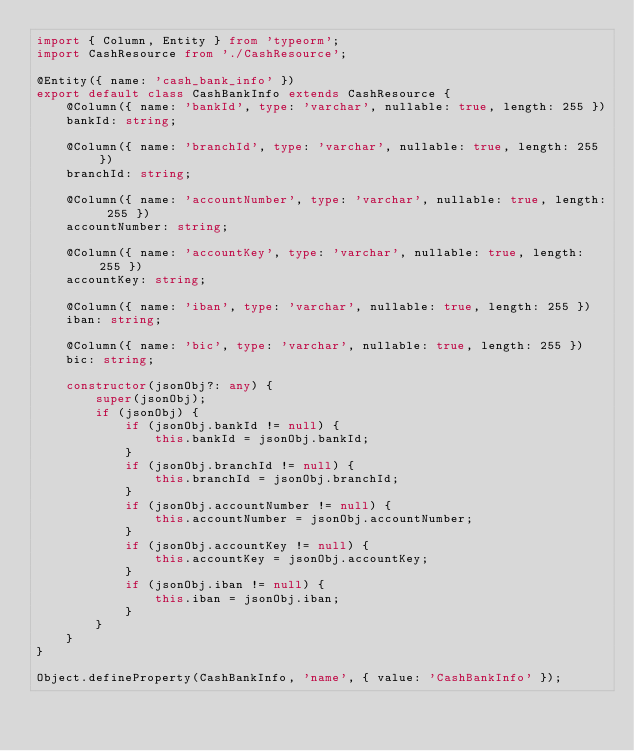Convert code to text. <code><loc_0><loc_0><loc_500><loc_500><_TypeScript_>import { Column, Entity } from 'typeorm';
import CashResource from './CashResource';

@Entity({ name: 'cash_bank_info' })
export default class CashBankInfo extends CashResource {
    @Column({ name: 'bankId', type: 'varchar', nullable: true, length: 255 })
    bankId: string;

    @Column({ name: 'branchId', type: 'varchar', nullable: true, length: 255 })
    branchId: string;

    @Column({ name: 'accountNumber', type: 'varchar', nullable: true, length: 255 })
    accountNumber: string;

    @Column({ name: 'accountKey', type: 'varchar', nullable: true, length: 255 })
    accountKey: string;

    @Column({ name: 'iban', type: 'varchar', nullable: true, length: 255 })
    iban: string;

    @Column({ name: 'bic', type: 'varchar', nullable: true, length: 255 })
    bic: string;

    constructor(jsonObj?: any) {
        super(jsonObj);
        if (jsonObj) {
            if (jsonObj.bankId != null) {
                this.bankId = jsonObj.bankId;
            }
            if (jsonObj.branchId != null) {
                this.branchId = jsonObj.branchId;
            }
            if (jsonObj.accountNumber != null) {
                this.accountNumber = jsonObj.accountNumber;
            }
            if (jsonObj.accountKey != null) {
                this.accountKey = jsonObj.accountKey;
            }
            if (jsonObj.iban != null) {
                this.iban = jsonObj.iban;
            }
        }
    }
}

Object.defineProperty(CashBankInfo, 'name', { value: 'CashBankInfo' });
</code> 